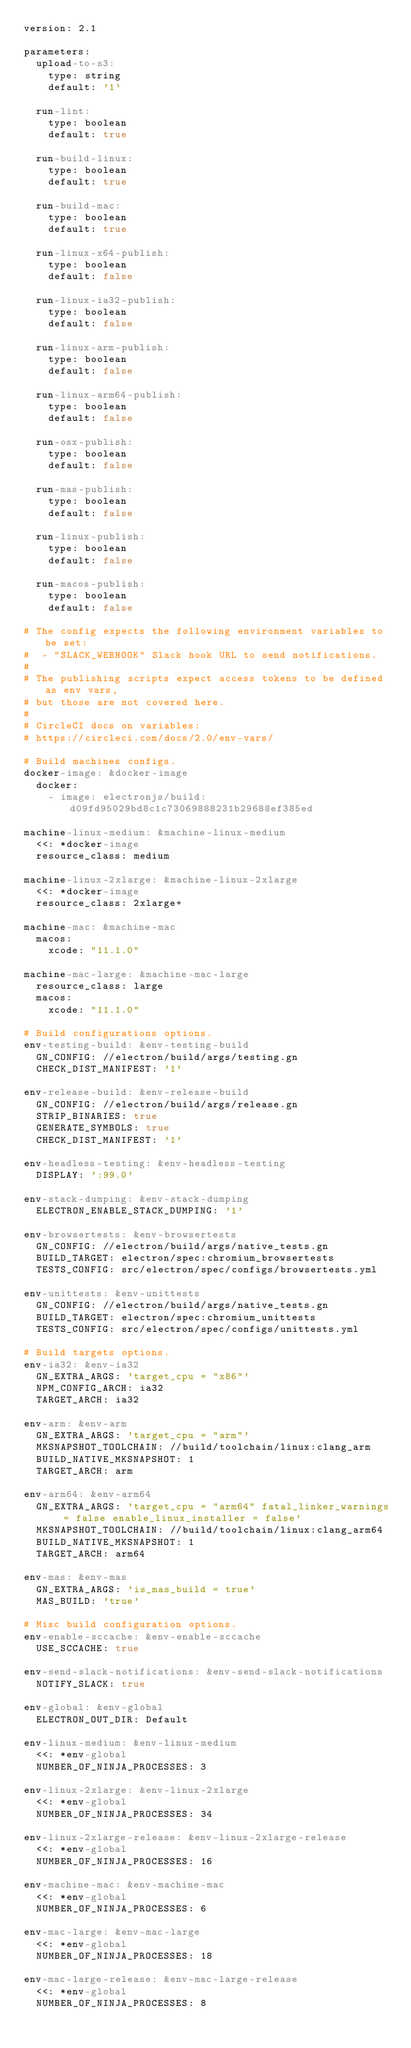Convert code to text. <code><loc_0><loc_0><loc_500><loc_500><_YAML_>version: 2.1

parameters:
  upload-to-s3:
    type: string
    default: '1'

  run-lint:
    type: boolean
    default: true

  run-build-linux:
    type: boolean
    default: true

  run-build-mac:
    type: boolean
    default: true

  run-linux-x64-publish:
    type: boolean
    default: false

  run-linux-ia32-publish:
    type: boolean
    default: false

  run-linux-arm-publish:
    type: boolean
    default: false

  run-linux-arm64-publish:
    type: boolean
    default: false

  run-osx-publish:
    type: boolean
    default: false

  run-mas-publish:
    type: boolean
    default: false

  run-linux-publish:
    type: boolean
    default: false

  run-macos-publish:
    type: boolean
    default: false

# The config expects the following environment variables to be set:
#  - "SLACK_WEBHOOK" Slack hook URL to send notifications.
#
# The publishing scripts expect access tokens to be defined as env vars,
# but those are not covered here.
#
# CircleCI docs on variables:
# https://circleci.com/docs/2.0/env-vars/

# Build machines configs.
docker-image: &docker-image
  docker:
    - image: electronjs/build:d09fd95029bd8c1c73069888231b29688ef385ed

machine-linux-medium: &machine-linux-medium
  <<: *docker-image
  resource_class: medium

machine-linux-2xlarge: &machine-linux-2xlarge
  <<: *docker-image
  resource_class: 2xlarge+

machine-mac: &machine-mac
  macos:
    xcode: "11.1.0"

machine-mac-large: &machine-mac-large
  resource_class: large
  macos:
    xcode: "11.1.0"

# Build configurations options.
env-testing-build: &env-testing-build
  GN_CONFIG: //electron/build/args/testing.gn
  CHECK_DIST_MANIFEST: '1'

env-release-build: &env-release-build
  GN_CONFIG: //electron/build/args/release.gn
  STRIP_BINARIES: true
  GENERATE_SYMBOLS: true
  CHECK_DIST_MANIFEST: '1'

env-headless-testing: &env-headless-testing
  DISPLAY: ':99.0'

env-stack-dumping: &env-stack-dumping
  ELECTRON_ENABLE_STACK_DUMPING: '1'

env-browsertests: &env-browsertests
  GN_CONFIG: //electron/build/args/native_tests.gn
  BUILD_TARGET: electron/spec:chromium_browsertests
  TESTS_CONFIG: src/electron/spec/configs/browsertests.yml

env-unittests: &env-unittests
  GN_CONFIG: //electron/build/args/native_tests.gn
  BUILD_TARGET: electron/spec:chromium_unittests
  TESTS_CONFIG: src/electron/spec/configs/unittests.yml

# Build targets options.
env-ia32: &env-ia32
  GN_EXTRA_ARGS: 'target_cpu = "x86"'
  NPM_CONFIG_ARCH: ia32
  TARGET_ARCH: ia32

env-arm: &env-arm
  GN_EXTRA_ARGS: 'target_cpu = "arm"'
  MKSNAPSHOT_TOOLCHAIN: //build/toolchain/linux:clang_arm
  BUILD_NATIVE_MKSNAPSHOT: 1
  TARGET_ARCH: arm

env-arm64: &env-arm64
  GN_EXTRA_ARGS: 'target_cpu = "arm64" fatal_linker_warnings = false enable_linux_installer = false'
  MKSNAPSHOT_TOOLCHAIN: //build/toolchain/linux:clang_arm64
  BUILD_NATIVE_MKSNAPSHOT: 1
  TARGET_ARCH: arm64

env-mas: &env-mas
  GN_EXTRA_ARGS: 'is_mas_build = true'
  MAS_BUILD: 'true'

# Misc build configuration options.
env-enable-sccache: &env-enable-sccache
  USE_SCCACHE: true

env-send-slack-notifications: &env-send-slack-notifications
  NOTIFY_SLACK: true
  
env-global: &env-global
  ELECTRON_OUT_DIR: Default

env-linux-medium: &env-linux-medium
  <<: *env-global
  NUMBER_OF_NINJA_PROCESSES: 3

env-linux-2xlarge: &env-linux-2xlarge
  <<: *env-global
  NUMBER_OF_NINJA_PROCESSES: 34

env-linux-2xlarge-release: &env-linux-2xlarge-release
  <<: *env-global
  NUMBER_OF_NINJA_PROCESSES: 16

env-machine-mac: &env-machine-mac
  <<: *env-global
  NUMBER_OF_NINJA_PROCESSES: 6

env-mac-large: &env-mac-large
  <<: *env-global
  NUMBER_OF_NINJA_PROCESSES: 18

env-mac-large-release: &env-mac-large-release
  <<: *env-global
  NUMBER_OF_NINJA_PROCESSES: 8
</code> 